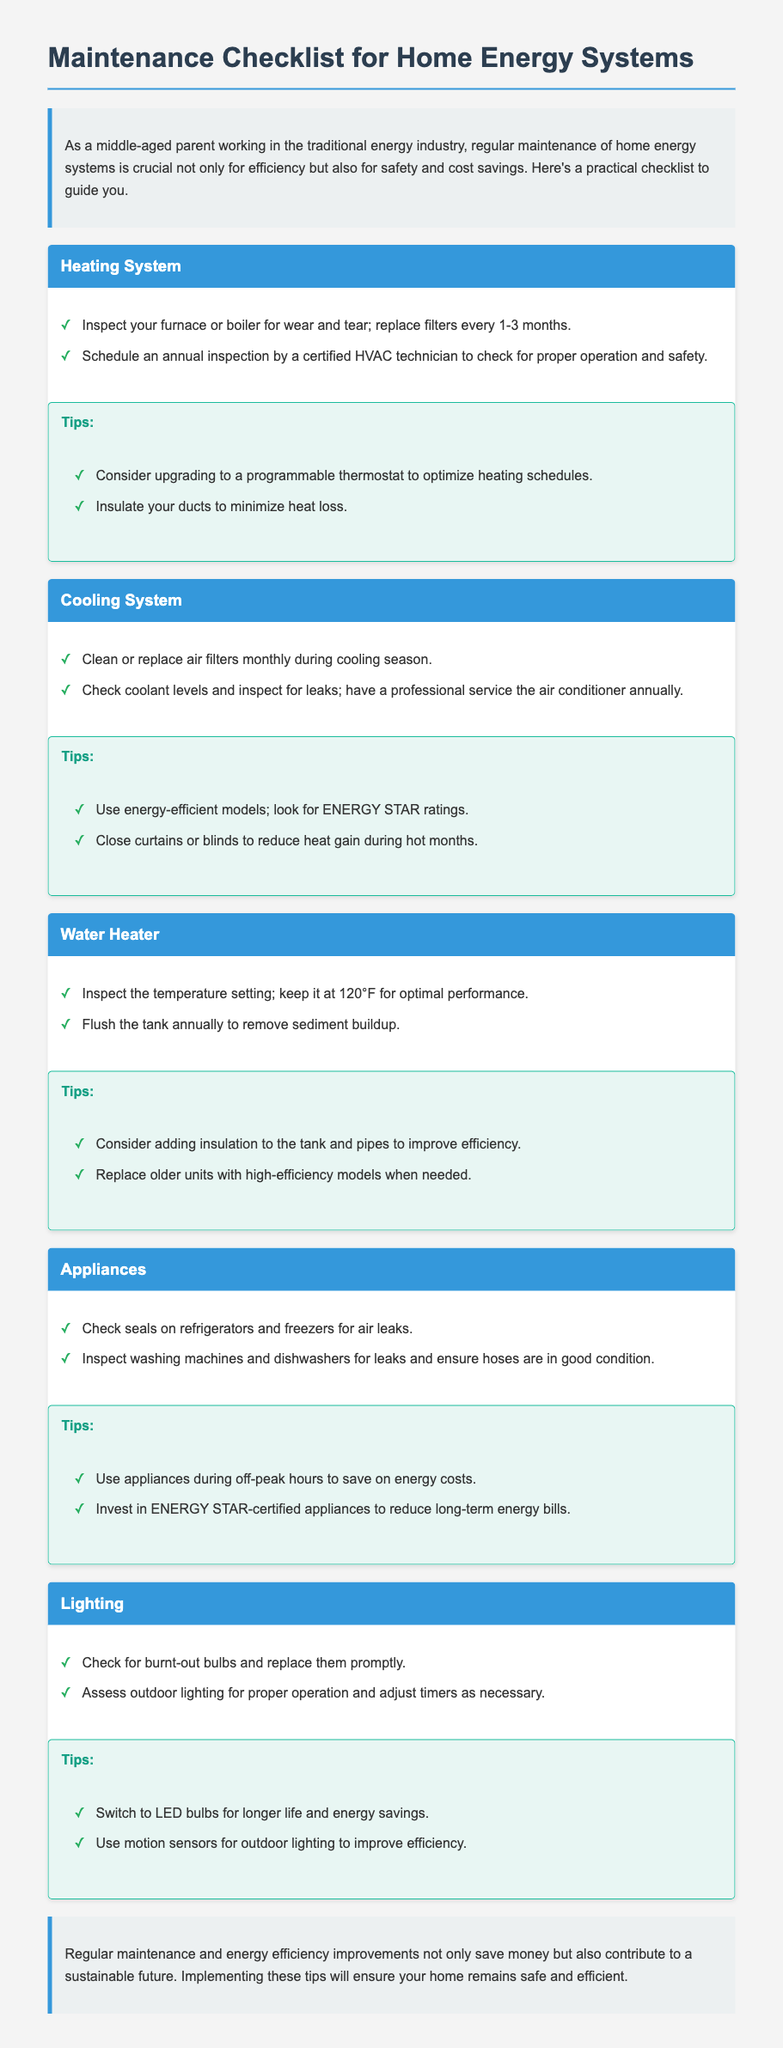What should you check for in your furnace or boiler? The document states that you should inspect your furnace or boiler for wear and tear.
Answer: Wear and tear How often should filters be replaced? It specifies that filters should be replaced every 1-3 months.
Answer: Every 1-3 months What temperature should the water heater be set at? The document recommends keeping the temperature setting at 120°F for optimal performance.
Answer: 120°F What is one tip for energy-efficient cooling? It suggests using energy-efficient models and looking for ENERGY STAR ratings.
Answer: ENERGY STAR ratings How often should air filters be cleaned or replaced during the cooling season? The document indicates that air filters should be cleaned or replaced monthly during the cooling season.
Answer: Monthly What should be done to the water heater annually? It states that you should flush the tank annually to remove sediment buildup.
Answer: Flush the tank What type of appliances are recommended for long-term energy savings? The document advises investing in ENERGY STAR-certified appliances.
Answer: ENERGY STAR-certified appliances What is a suggested improvement for outdoor lighting? It recommends using motion sensors for outdoor lighting to improve efficiency.
Answer: Motion sensors How can you save on energy costs when using appliances? The document suggests using appliances during off-peak hours to save energy costs.
Answer: Off-peak hours 